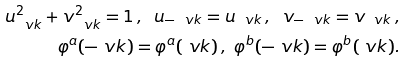Convert formula to latex. <formula><loc_0><loc_0><loc_500><loc_500>u _ { \ v k } ^ { 2 } + v _ { \ v k } ^ { 2 } = 1 \, , \ u _ { - \ v k } = u _ { \ v k } \, , \ v _ { - \ v k } = v _ { \ v k } \, , \\ \varphi ^ { a } ( - \ v k ) = \varphi ^ { a } ( \ v k ) \, , \ \varphi ^ { b } ( - \ v k ) = \varphi ^ { b } ( \ v k ) .</formula> 